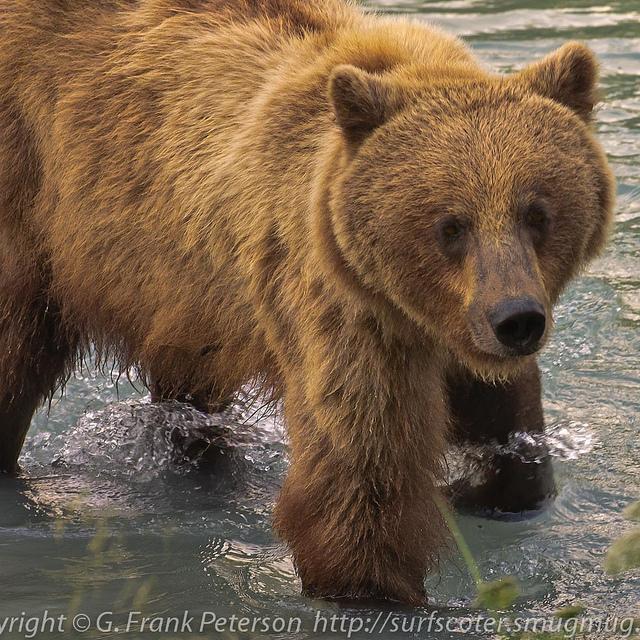Is the water frozen?
Keep it brief. No. Is the bear standing in the water?
Answer briefly. Yes. What color is this bear?
Keep it brief. Brown. 